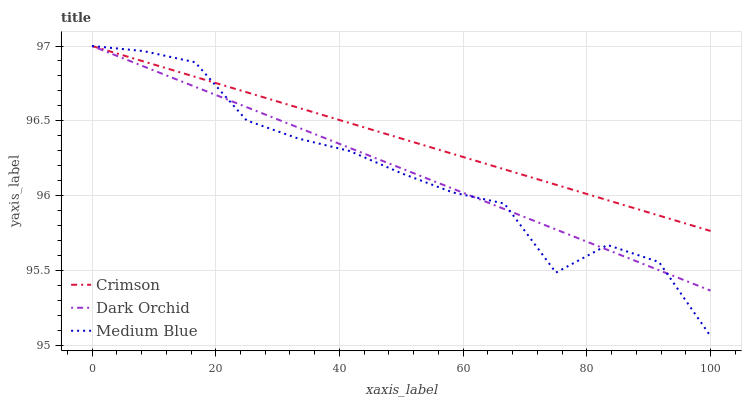Does Medium Blue have the minimum area under the curve?
Answer yes or no. Yes. Does Crimson have the maximum area under the curve?
Answer yes or no. Yes. Does Dark Orchid have the minimum area under the curve?
Answer yes or no. No. Does Dark Orchid have the maximum area under the curve?
Answer yes or no. No. Is Dark Orchid the smoothest?
Answer yes or no. Yes. Is Medium Blue the roughest?
Answer yes or no. Yes. Is Medium Blue the smoothest?
Answer yes or no. No. Is Dark Orchid the roughest?
Answer yes or no. No. Does Dark Orchid have the lowest value?
Answer yes or no. No. Does Dark Orchid have the highest value?
Answer yes or no. Yes. Does Crimson intersect Dark Orchid?
Answer yes or no. Yes. Is Crimson less than Dark Orchid?
Answer yes or no. No. Is Crimson greater than Dark Orchid?
Answer yes or no. No. 